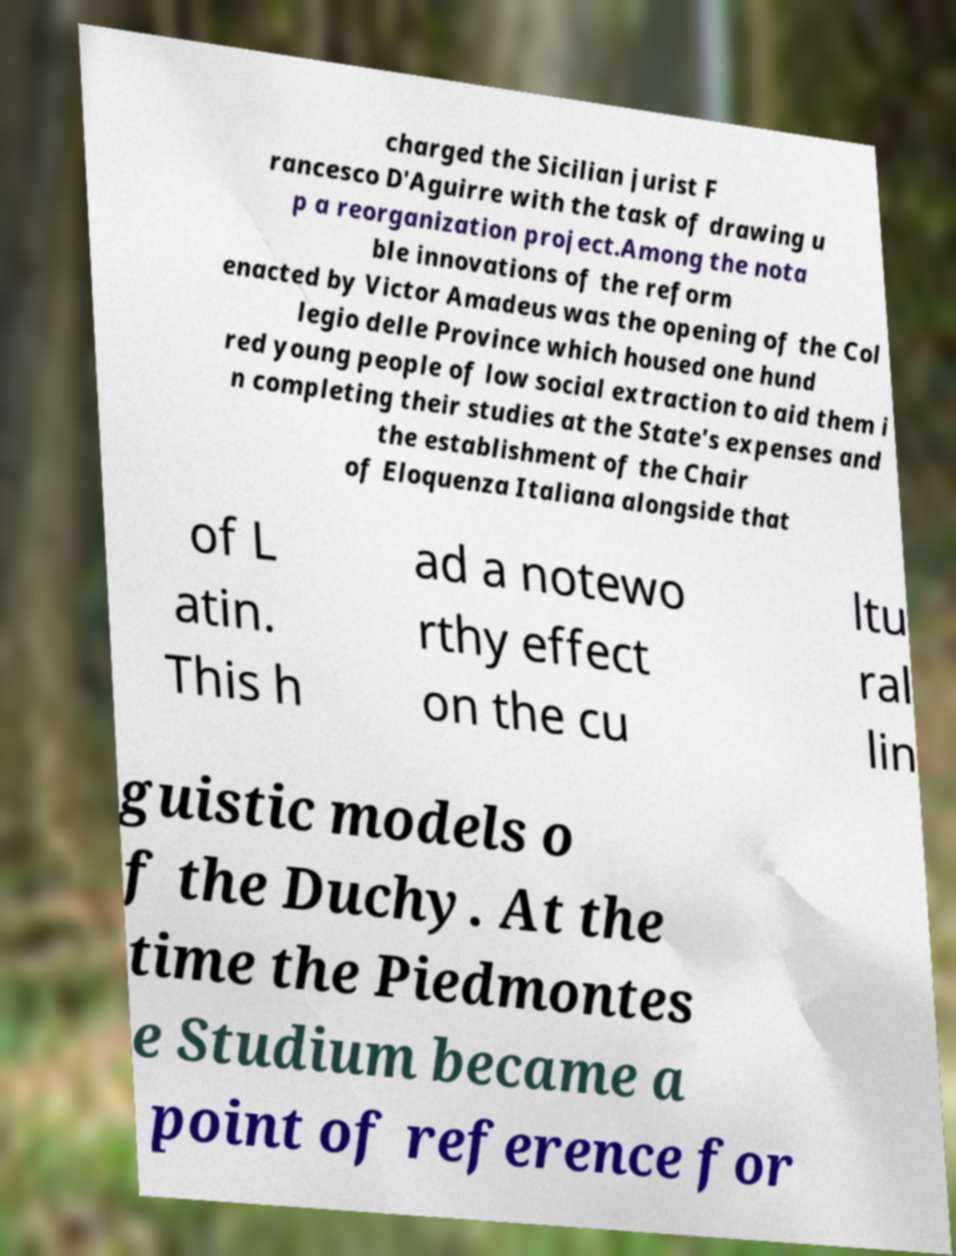Could you assist in decoding the text presented in this image and type it out clearly? charged the Sicilian jurist F rancesco D'Aguirre with the task of drawing u p a reorganization project.Among the nota ble innovations of the reform enacted by Victor Amadeus was the opening of the Col legio delle Province which housed one hund red young people of low social extraction to aid them i n completing their studies at the State's expenses and the establishment of the Chair of Eloquenza Italiana alongside that of L atin. This h ad a notewo rthy effect on the cu ltu ral lin guistic models o f the Duchy. At the time the Piedmontes e Studium became a point of reference for 